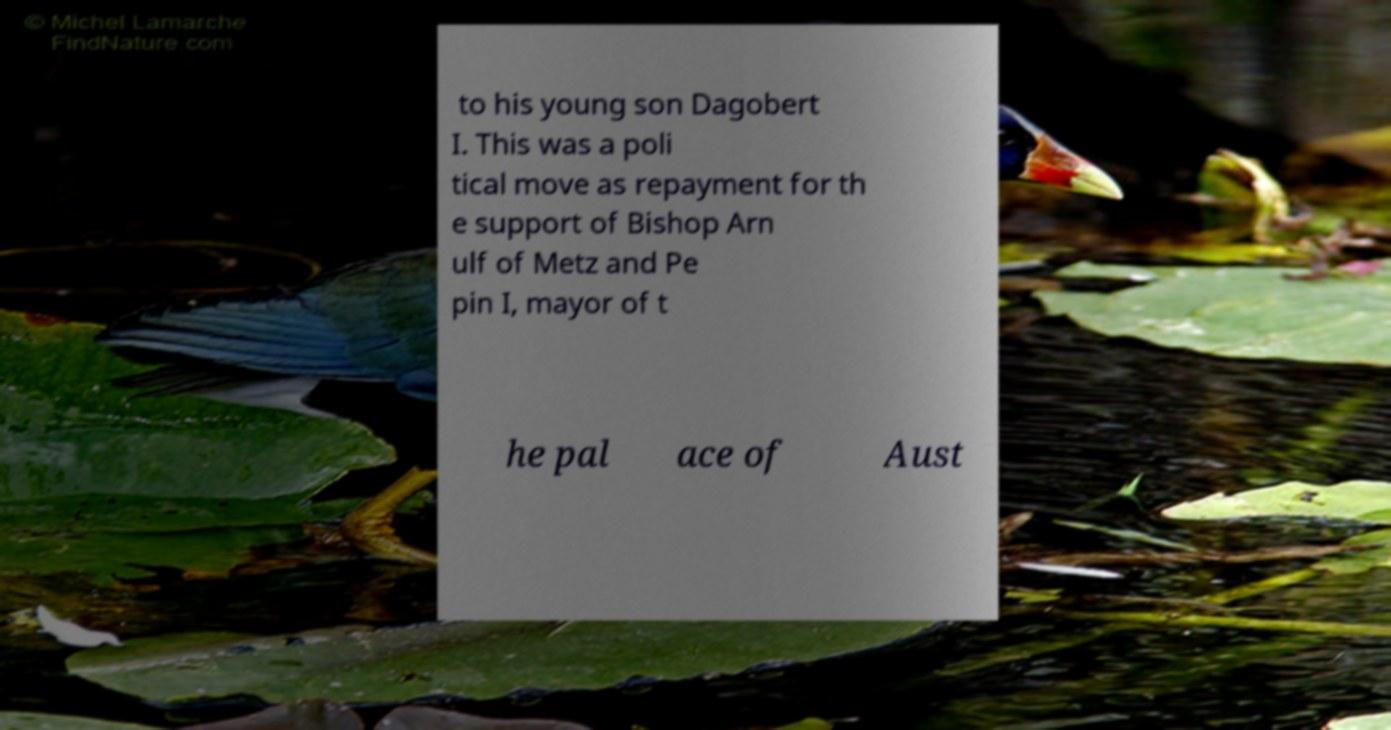Please identify and transcribe the text found in this image. to his young son Dagobert I. This was a poli tical move as repayment for th e support of Bishop Arn ulf of Metz and Pe pin I, mayor of t he pal ace of Aust 